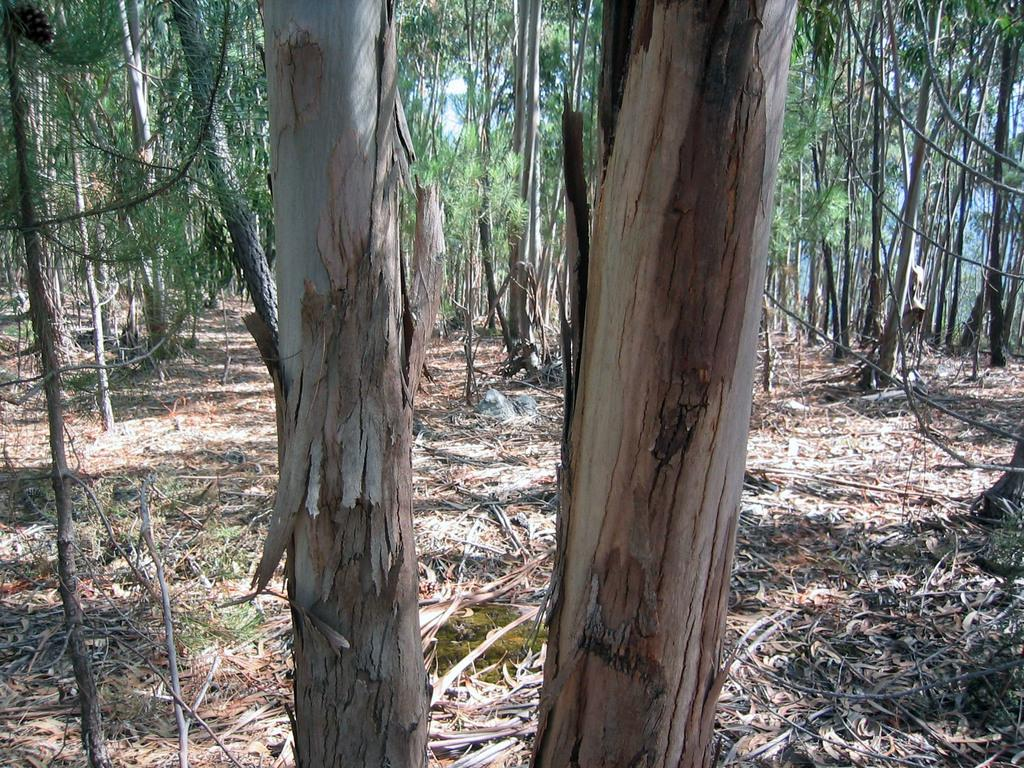Where was the image taken? The image was clicked outside the city. What can be seen in the foreground of the image? There are tree trunks in the foreground of the image. What is visible in the background of the image? The ground and trees are visible in the background of the image. What advice do the boys in the image give to the viewer? There are no boys present in the image, so no advice can be given. 